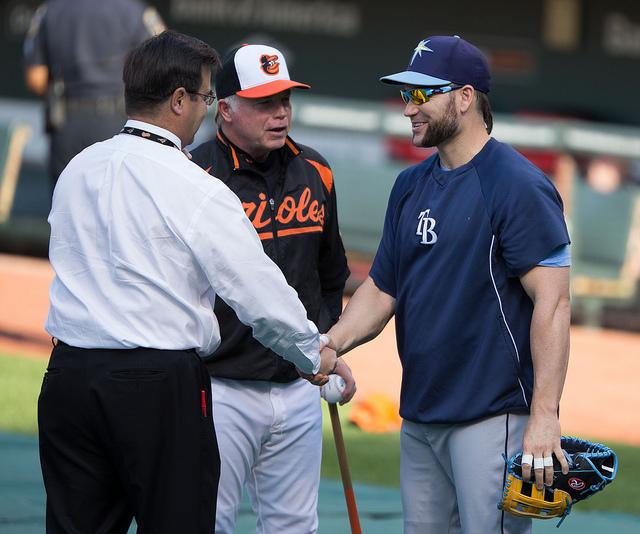What are these people participating in?
Write a very short answer. Baseball. Do the couple know each other?
Concise answer only. Yes. Is there tape on the mans pinky finger?
Give a very brief answer. No. Are the men shaking hands?
Give a very brief answer. Yes. 